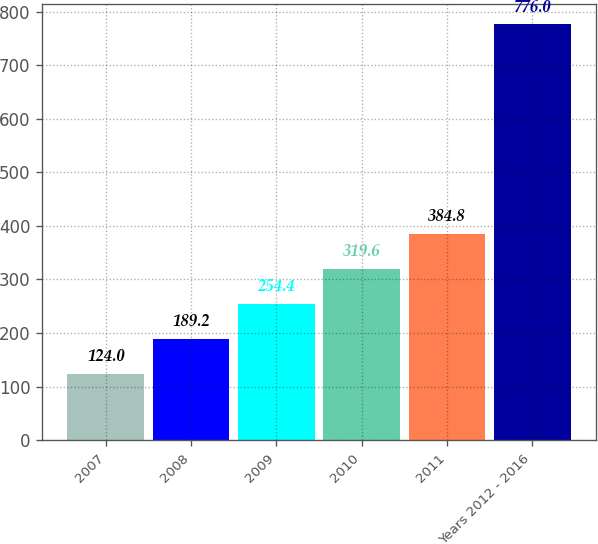Convert chart. <chart><loc_0><loc_0><loc_500><loc_500><bar_chart><fcel>2007<fcel>2008<fcel>2009<fcel>2010<fcel>2011<fcel>Years 2012 - 2016<nl><fcel>124<fcel>189.2<fcel>254.4<fcel>319.6<fcel>384.8<fcel>776<nl></chart> 